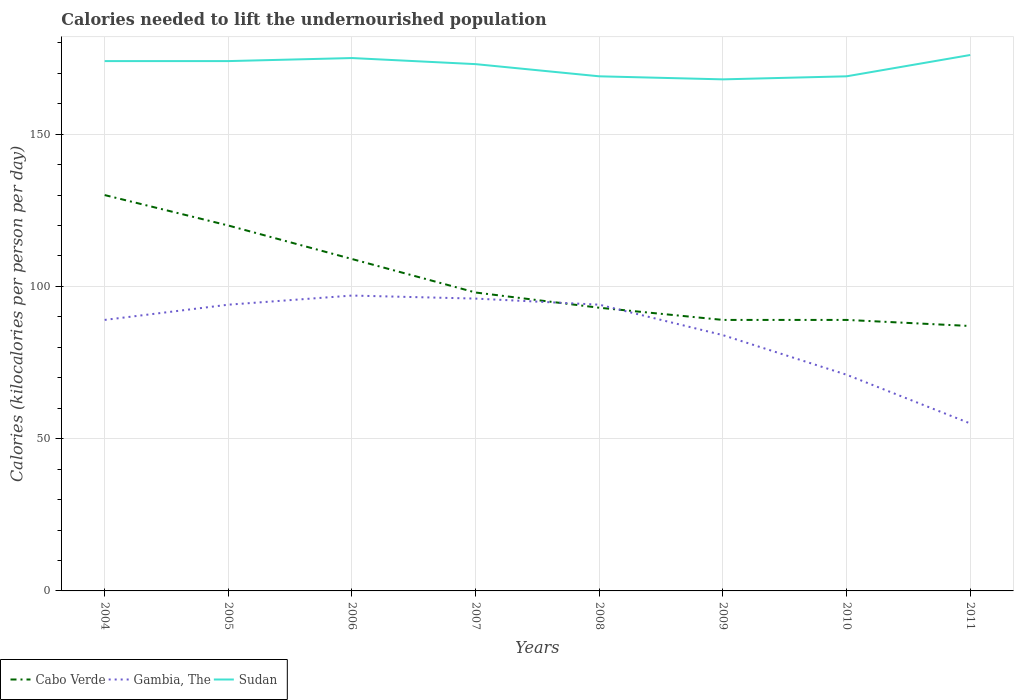How many different coloured lines are there?
Make the answer very short. 3. Does the line corresponding to Cabo Verde intersect with the line corresponding to Sudan?
Provide a succinct answer. No. Across all years, what is the maximum total calories needed to lift the undernourished population in Gambia, The?
Keep it short and to the point. 55. In which year was the total calories needed to lift the undernourished population in Gambia, The maximum?
Provide a succinct answer. 2011. What is the total total calories needed to lift the undernourished population in Gambia, The in the graph?
Give a very brief answer. -7. What is the difference between the highest and the second highest total calories needed to lift the undernourished population in Gambia, The?
Keep it short and to the point. 42. Is the total calories needed to lift the undernourished population in Cabo Verde strictly greater than the total calories needed to lift the undernourished population in Gambia, The over the years?
Your answer should be very brief. No. What is the difference between two consecutive major ticks on the Y-axis?
Provide a short and direct response. 50. Does the graph contain any zero values?
Provide a short and direct response. No. Where does the legend appear in the graph?
Give a very brief answer. Bottom left. How many legend labels are there?
Keep it short and to the point. 3. How are the legend labels stacked?
Provide a short and direct response. Horizontal. What is the title of the graph?
Keep it short and to the point. Calories needed to lift the undernourished population. Does "Sweden" appear as one of the legend labels in the graph?
Provide a short and direct response. No. What is the label or title of the Y-axis?
Your answer should be very brief. Calories (kilocalories per person per day). What is the Calories (kilocalories per person per day) in Cabo Verde in 2004?
Offer a very short reply. 130. What is the Calories (kilocalories per person per day) of Gambia, The in 2004?
Offer a very short reply. 89. What is the Calories (kilocalories per person per day) of Sudan in 2004?
Offer a very short reply. 174. What is the Calories (kilocalories per person per day) in Cabo Verde in 2005?
Provide a succinct answer. 120. What is the Calories (kilocalories per person per day) in Gambia, The in 2005?
Offer a terse response. 94. What is the Calories (kilocalories per person per day) of Sudan in 2005?
Provide a succinct answer. 174. What is the Calories (kilocalories per person per day) in Cabo Verde in 2006?
Offer a terse response. 109. What is the Calories (kilocalories per person per day) of Gambia, The in 2006?
Ensure brevity in your answer.  97. What is the Calories (kilocalories per person per day) of Sudan in 2006?
Give a very brief answer. 175. What is the Calories (kilocalories per person per day) in Gambia, The in 2007?
Make the answer very short. 96. What is the Calories (kilocalories per person per day) of Sudan in 2007?
Provide a short and direct response. 173. What is the Calories (kilocalories per person per day) of Cabo Verde in 2008?
Ensure brevity in your answer.  93. What is the Calories (kilocalories per person per day) of Gambia, The in 2008?
Your answer should be very brief. 94. What is the Calories (kilocalories per person per day) in Sudan in 2008?
Your answer should be compact. 169. What is the Calories (kilocalories per person per day) in Cabo Verde in 2009?
Your answer should be compact. 89. What is the Calories (kilocalories per person per day) of Sudan in 2009?
Offer a very short reply. 168. What is the Calories (kilocalories per person per day) of Cabo Verde in 2010?
Your response must be concise. 89. What is the Calories (kilocalories per person per day) of Sudan in 2010?
Offer a very short reply. 169. What is the Calories (kilocalories per person per day) of Cabo Verde in 2011?
Provide a short and direct response. 87. What is the Calories (kilocalories per person per day) in Sudan in 2011?
Make the answer very short. 176. Across all years, what is the maximum Calories (kilocalories per person per day) of Cabo Verde?
Your answer should be compact. 130. Across all years, what is the maximum Calories (kilocalories per person per day) in Gambia, The?
Give a very brief answer. 97. Across all years, what is the maximum Calories (kilocalories per person per day) of Sudan?
Ensure brevity in your answer.  176. Across all years, what is the minimum Calories (kilocalories per person per day) of Cabo Verde?
Your answer should be compact. 87. Across all years, what is the minimum Calories (kilocalories per person per day) in Sudan?
Give a very brief answer. 168. What is the total Calories (kilocalories per person per day) in Cabo Verde in the graph?
Your response must be concise. 815. What is the total Calories (kilocalories per person per day) of Gambia, The in the graph?
Your answer should be very brief. 680. What is the total Calories (kilocalories per person per day) in Sudan in the graph?
Make the answer very short. 1378. What is the difference between the Calories (kilocalories per person per day) in Cabo Verde in 2004 and that in 2005?
Give a very brief answer. 10. What is the difference between the Calories (kilocalories per person per day) of Sudan in 2004 and that in 2005?
Your answer should be very brief. 0. What is the difference between the Calories (kilocalories per person per day) in Gambia, The in 2004 and that in 2006?
Provide a succinct answer. -8. What is the difference between the Calories (kilocalories per person per day) in Gambia, The in 2004 and that in 2007?
Offer a very short reply. -7. What is the difference between the Calories (kilocalories per person per day) in Sudan in 2004 and that in 2007?
Your response must be concise. 1. What is the difference between the Calories (kilocalories per person per day) of Gambia, The in 2004 and that in 2008?
Provide a short and direct response. -5. What is the difference between the Calories (kilocalories per person per day) in Cabo Verde in 2004 and that in 2009?
Provide a succinct answer. 41. What is the difference between the Calories (kilocalories per person per day) of Sudan in 2004 and that in 2009?
Provide a succinct answer. 6. What is the difference between the Calories (kilocalories per person per day) in Gambia, The in 2004 and that in 2010?
Keep it short and to the point. 18. What is the difference between the Calories (kilocalories per person per day) of Sudan in 2004 and that in 2010?
Make the answer very short. 5. What is the difference between the Calories (kilocalories per person per day) of Gambia, The in 2005 and that in 2006?
Provide a short and direct response. -3. What is the difference between the Calories (kilocalories per person per day) in Sudan in 2005 and that in 2006?
Your answer should be compact. -1. What is the difference between the Calories (kilocalories per person per day) of Gambia, The in 2005 and that in 2007?
Give a very brief answer. -2. What is the difference between the Calories (kilocalories per person per day) of Sudan in 2005 and that in 2007?
Provide a short and direct response. 1. What is the difference between the Calories (kilocalories per person per day) of Cabo Verde in 2005 and that in 2008?
Provide a succinct answer. 27. What is the difference between the Calories (kilocalories per person per day) in Cabo Verde in 2005 and that in 2009?
Provide a short and direct response. 31. What is the difference between the Calories (kilocalories per person per day) in Gambia, The in 2005 and that in 2009?
Your answer should be compact. 10. What is the difference between the Calories (kilocalories per person per day) in Cabo Verde in 2005 and that in 2010?
Your answer should be compact. 31. What is the difference between the Calories (kilocalories per person per day) in Sudan in 2005 and that in 2011?
Make the answer very short. -2. What is the difference between the Calories (kilocalories per person per day) of Sudan in 2006 and that in 2007?
Provide a succinct answer. 2. What is the difference between the Calories (kilocalories per person per day) in Cabo Verde in 2006 and that in 2008?
Offer a terse response. 16. What is the difference between the Calories (kilocalories per person per day) in Gambia, The in 2006 and that in 2008?
Provide a short and direct response. 3. What is the difference between the Calories (kilocalories per person per day) of Cabo Verde in 2006 and that in 2009?
Offer a very short reply. 20. What is the difference between the Calories (kilocalories per person per day) in Gambia, The in 2006 and that in 2009?
Provide a succinct answer. 13. What is the difference between the Calories (kilocalories per person per day) in Sudan in 2006 and that in 2009?
Provide a short and direct response. 7. What is the difference between the Calories (kilocalories per person per day) in Sudan in 2006 and that in 2010?
Offer a very short reply. 6. What is the difference between the Calories (kilocalories per person per day) in Cabo Verde in 2007 and that in 2009?
Provide a short and direct response. 9. What is the difference between the Calories (kilocalories per person per day) of Gambia, The in 2007 and that in 2009?
Offer a very short reply. 12. What is the difference between the Calories (kilocalories per person per day) of Gambia, The in 2007 and that in 2010?
Your response must be concise. 25. What is the difference between the Calories (kilocalories per person per day) in Gambia, The in 2008 and that in 2009?
Offer a terse response. 10. What is the difference between the Calories (kilocalories per person per day) of Sudan in 2008 and that in 2009?
Ensure brevity in your answer.  1. What is the difference between the Calories (kilocalories per person per day) in Cabo Verde in 2008 and that in 2010?
Your answer should be compact. 4. What is the difference between the Calories (kilocalories per person per day) of Sudan in 2008 and that in 2010?
Give a very brief answer. 0. What is the difference between the Calories (kilocalories per person per day) in Sudan in 2008 and that in 2011?
Ensure brevity in your answer.  -7. What is the difference between the Calories (kilocalories per person per day) of Cabo Verde in 2009 and that in 2010?
Ensure brevity in your answer.  0. What is the difference between the Calories (kilocalories per person per day) of Gambia, The in 2009 and that in 2010?
Offer a very short reply. 13. What is the difference between the Calories (kilocalories per person per day) of Sudan in 2009 and that in 2010?
Your response must be concise. -1. What is the difference between the Calories (kilocalories per person per day) in Cabo Verde in 2009 and that in 2011?
Your answer should be very brief. 2. What is the difference between the Calories (kilocalories per person per day) of Cabo Verde in 2010 and that in 2011?
Ensure brevity in your answer.  2. What is the difference between the Calories (kilocalories per person per day) of Sudan in 2010 and that in 2011?
Offer a very short reply. -7. What is the difference between the Calories (kilocalories per person per day) in Cabo Verde in 2004 and the Calories (kilocalories per person per day) in Gambia, The in 2005?
Ensure brevity in your answer.  36. What is the difference between the Calories (kilocalories per person per day) in Cabo Verde in 2004 and the Calories (kilocalories per person per day) in Sudan in 2005?
Your answer should be very brief. -44. What is the difference between the Calories (kilocalories per person per day) in Gambia, The in 2004 and the Calories (kilocalories per person per day) in Sudan in 2005?
Your response must be concise. -85. What is the difference between the Calories (kilocalories per person per day) of Cabo Verde in 2004 and the Calories (kilocalories per person per day) of Sudan in 2006?
Provide a succinct answer. -45. What is the difference between the Calories (kilocalories per person per day) in Gambia, The in 2004 and the Calories (kilocalories per person per day) in Sudan in 2006?
Make the answer very short. -86. What is the difference between the Calories (kilocalories per person per day) in Cabo Verde in 2004 and the Calories (kilocalories per person per day) in Sudan in 2007?
Provide a succinct answer. -43. What is the difference between the Calories (kilocalories per person per day) of Gambia, The in 2004 and the Calories (kilocalories per person per day) of Sudan in 2007?
Offer a very short reply. -84. What is the difference between the Calories (kilocalories per person per day) in Cabo Verde in 2004 and the Calories (kilocalories per person per day) in Gambia, The in 2008?
Offer a very short reply. 36. What is the difference between the Calories (kilocalories per person per day) in Cabo Verde in 2004 and the Calories (kilocalories per person per day) in Sudan in 2008?
Your answer should be very brief. -39. What is the difference between the Calories (kilocalories per person per day) of Gambia, The in 2004 and the Calories (kilocalories per person per day) of Sudan in 2008?
Your response must be concise. -80. What is the difference between the Calories (kilocalories per person per day) in Cabo Verde in 2004 and the Calories (kilocalories per person per day) in Sudan in 2009?
Make the answer very short. -38. What is the difference between the Calories (kilocalories per person per day) of Gambia, The in 2004 and the Calories (kilocalories per person per day) of Sudan in 2009?
Your response must be concise. -79. What is the difference between the Calories (kilocalories per person per day) in Cabo Verde in 2004 and the Calories (kilocalories per person per day) in Sudan in 2010?
Give a very brief answer. -39. What is the difference between the Calories (kilocalories per person per day) in Gambia, The in 2004 and the Calories (kilocalories per person per day) in Sudan in 2010?
Your response must be concise. -80. What is the difference between the Calories (kilocalories per person per day) in Cabo Verde in 2004 and the Calories (kilocalories per person per day) in Gambia, The in 2011?
Provide a succinct answer. 75. What is the difference between the Calories (kilocalories per person per day) in Cabo Verde in 2004 and the Calories (kilocalories per person per day) in Sudan in 2011?
Give a very brief answer. -46. What is the difference between the Calories (kilocalories per person per day) in Gambia, The in 2004 and the Calories (kilocalories per person per day) in Sudan in 2011?
Your response must be concise. -87. What is the difference between the Calories (kilocalories per person per day) in Cabo Verde in 2005 and the Calories (kilocalories per person per day) in Gambia, The in 2006?
Your response must be concise. 23. What is the difference between the Calories (kilocalories per person per day) in Cabo Verde in 2005 and the Calories (kilocalories per person per day) in Sudan in 2006?
Give a very brief answer. -55. What is the difference between the Calories (kilocalories per person per day) of Gambia, The in 2005 and the Calories (kilocalories per person per day) of Sudan in 2006?
Keep it short and to the point. -81. What is the difference between the Calories (kilocalories per person per day) of Cabo Verde in 2005 and the Calories (kilocalories per person per day) of Gambia, The in 2007?
Your response must be concise. 24. What is the difference between the Calories (kilocalories per person per day) of Cabo Verde in 2005 and the Calories (kilocalories per person per day) of Sudan in 2007?
Give a very brief answer. -53. What is the difference between the Calories (kilocalories per person per day) of Gambia, The in 2005 and the Calories (kilocalories per person per day) of Sudan in 2007?
Offer a terse response. -79. What is the difference between the Calories (kilocalories per person per day) of Cabo Verde in 2005 and the Calories (kilocalories per person per day) of Sudan in 2008?
Keep it short and to the point. -49. What is the difference between the Calories (kilocalories per person per day) of Gambia, The in 2005 and the Calories (kilocalories per person per day) of Sudan in 2008?
Provide a short and direct response. -75. What is the difference between the Calories (kilocalories per person per day) in Cabo Verde in 2005 and the Calories (kilocalories per person per day) in Sudan in 2009?
Give a very brief answer. -48. What is the difference between the Calories (kilocalories per person per day) in Gambia, The in 2005 and the Calories (kilocalories per person per day) in Sudan in 2009?
Your response must be concise. -74. What is the difference between the Calories (kilocalories per person per day) in Cabo Verde in 2005 and the Calories (kilocalories per person per day) in Gambia, The in 2010?
Provide a succinct answer. 49. What is the difference between the Calories (kilocalories per person per day) in Cabo Verde in 2005 and the Calories (kilocalories per person per day) in Sudan in 2010?
Your answer should be very brief. -49. What is the difference between the Calories (kilocalories per person per day) of Gambia, The in 2005 and the Calories (kilocalories per person per day) of Sudan in 2010?
Your answer should be compact. -75. What is the difference between the Calories (kilocalories per person per day) of Cabo Verde in 2005 and the Calories (kilocalories per person per day) of Gambia, The in 2011?
Keep it short and to the point. 65. What is the difference between the Calories (kilocalories per person per day) of Cabo Verde in 2005 and the Calories (kilocalories per person per day) of Sudan in 2011?
Give a very brief answer. -56. What is the difference between the Calories (kilocalories per person per day) of Gambia, The in 2005 and the Calories (kilocalories per person per day) of Sudan in 2011?
Provide a short and direct response. -82. What is the difference between the Calories (kilocalories per person per day) of Cabo Verde in 2006 and the Calories (kilocalories per person per day) of Sudan in 2007?
Your answer should be compact. -64. What is the difference between the Calories (kilocalories per person per day) in Gambia, The in 2006 and the Calories (kilocalories per person per day) in Sudan in 2007?
Offer a terse response. -76. What is the difference between the Calories (kilocalories per person per day) of Cabo Verde in 2006 and the Calories (kilocalories per person per day) of Gambia, The in 2008?
Make the answer very short. 15. What is the difference between the Calories (kilocalories per person per day) in Cabo Verde in 2006 and the Calories (kilocalories per person per day) in Sudan in 2008?
Make the answer very short. -60. What is the difference between the Calories (kilocalories per person per day) in Gambia, The in 2006 and the Calories (kilocalories per person per day) in Sudan in 2008?
Your answer should be compact. -72. What is the difference between the Calories (kilocalories per person per day) in Cabo Verde in 2006 and the Calories (kilocalories per person per day) in Gambia, The in 2009?
Offer a terse response. 25. What is the difference between the Calories (kilocalories per person per day) of Cabo Verde in 2006 and the Calories (kilocalories per person per day) of Sudan in 2009?
Provide a succinct answer. -59. What is the difference between the Calories (kilocalories per person per day) of Gambia, The in 2006 and the Calories (kilocalories per person per day) of Sudan in 2009?
Offer a terse response. -71. What is the difference between the Calories (kilocalories per person per day) of Cabo Verde in 2006 and the Calories (kilocalories per person per day) of Sudan in 2010?
Your answer should be very brief. -60. What is the difference between the Calories (kilocalories per person per day) of Gambia, The in 2006 and the Calories (kilocalories per person per day) of Sudan in 2010?
Your response must be concise. -72. What is the difference between the Calories (kilocalories per person per day) of Cabo Verde in 2006 and the Calories (kilocalories per person per day) of Gambia, The in 2011?
Offer a terse response. 54. What is the difference between the Calories (kilocalories per person per day) in Cabo Verde in 2006 and the Calories (kilocalories per person per day) in Sudan in 2011?
Offer a terse response. -67. What is the difference between the Calories (kilocalories per person per day) of Gambia, The in 2006 and the Calories (kilocalories per person per day) of Sudan in 2011?
Offer a terse response. -79. What is the difference between the Calories (kilocalories per person per day) in Cabo Verde in 2007 and the Calories (kilocalories per person per day) in Sudan in 2008?
Provide a short and direct response. -71. What is the difference between the Calories (kilocalories per person per day) in Gambia, The in 2007 and the Calories (kilocalories per person per day) in Sudan in 2008?
Offer a very short reply. -73. What is the difference between the Calories (kilocalories per person per day) of Cabo Verde in 2007 and the Calories (kilocalories per person per day) of Sudan in 2009?
Offer a very short reply. -70. What is the difference between the Calories (kilocalories per person per day) in Gambia, The in 2007 and the Calories (kilocalories per person per day) in Sudan in 2009?
Make the answer very short. -72. What is the difference between the Calories (kilocalories per person per day) of Cabo Verde in 2007 and the Calories (kilocalories per person per day) of Gambia, The in 2010?
Provide a short and direct response. 27. What is the difference between the Calories (kilocalories per person per day) of Cabo Verde in 2007 and the Calories (kilocalories per person per day) of Sudan in 2010?
Your answer should be compact. -71. What is the difference between the Calories (kilocalories per person per day) in Gambia, The in 2007 and the Calories (kilocalories per person per day) in Sudan in 2010?
Provide a succinct answer. -73. What is the difference between the Calories (kilocalories per person per day) in Cabo Verde in 2007 and the Calories (kilocalories per person per day) in Sudan in 2011?
Offer a very short reply. -78. What is the difference between the Calories (kilocalories per person per day) of Gambia, The in 2007 and the Calories (kilocalories per person per day) of Sudan in 2011?
Provide a short and direct response. -80. What is the difference between the Calories (kilocalories per person per day) of Cabo Verde in 2008 and the Calories (kilocalories per person per day) of Sudan in 2009?
Your response must be concise. -75. What is the difference between the Calories (kilocalories per person per day) of Gambia, The in 2008 and the Calories (kilocalories per person per day) of Sudan in 2009?
Offer a terse response. -74. What is the difference between the Calories (kilocalories per person per day) of Cabo Verde in 2008 and the Calories (kilocalories per person per day) of Gambia, The in 2010?
Give a very brief answer. 22. What is the difference between the Calories (kilocalories per person per day) of Cabo Verde in 2008 and the Calories (kilocalories per person per day) of Sudan in 2010?
Make the answer very short. -76. What is the difference between the Calories (kilocalories per person per day) of Gambia, The in 2008 and the Calories (kilocalories per person per day) of Sudan in 2010?
Your response must be concise. -75. What is the difference between the Calories (kilocalories per person per day) of Cabo Verde in 2008 and the Calories (kilocalories per person per day) of Gambia, The in 2011?
Your answer should be compact. 38. What is the difference between the Calories (kilocalories per person per day) of Cabo Verde in 2008 and the Calories (kilocalories per person per day) of Sudan in 2011?
Provide a succinct answer. -83. What is the difference between the Calories (kilocalories per person per day) of Gambia, The in 2008 and the Calories (kilocalories per person per day) of Sudan in 2011?
Provide a succinct answer. -82. What is the difference between the Calories (kilocalories per person per day) in Cabo Verde in 2009 and the Calories (kilocalories per person per day) in Sudan in 2010?
Offer a terse response. -80. What is the difference between the Calories (kilocalories per person per day) in Gambia, The in 2009 and the Calories (kilocalories per person per day) in Sudan in 2010?
Make the answer very short. -85. What is the difference between the Calories (kilocalories per person per day) in Cabo Verde in 2009 and the Calories (kilocalories per person per day) in Sudan in 2011?
Your response must be concise. -87. What is the difference between the Calories (kilocalories per person per day) of Gambia, The in 2009 and the Calories (kilocalories per person per day) of Sudan in 2011?
Offer a terse response. -92. What is the difference between the Calories (kilocalories per person per day) of Cabo Verde in 2010 and the Calories (kilocalories per person per day) of Gambia, The in 2011?
Your answer should be very brief. 34. What is the difference between the Calories (kilocalories per person per day) in Cabo Verde in 2010 and the Calories (kilocalories per person per day) in Sudan in 2011?
Give a very brief answer. -87. What is the difference between the Calories (kilocalories per person per day) in Gambia, The in 2010 and the Calories (kilocalories per person per day) in Sudan in 2011?
Keep it short and to the point. -105. What is the average Calories (kilocalories per person per day) of Cabo Verde per year?
Give a very brief answer. 101.88. What is the average Calories (kilocalories per person per day) of Sudan per year?
Make the answer very short. 172.25. In the year 2004, what is the difference between the Calories (kilocalories per person per day) in Cabo Verde and Calories (kilocalories per person per day) in Gambia, The?
Provide a succinct answer. 41. In the year 2004, what is the difference between the Calories (kilocalories per person per day) in Cabo Verde and Calories (kilocalories per person per day) in Sudan?
Keep it short and to the point. -44. In the year 2004, what is the difference between the Calories (kilocalories per person per day) of Gambia, The and Calories (kilocalories per person per day) of Sudan?
Your response must be concise. -85. In the year 2005, what is the difference between the Calories (kilocalories per person per day) in Cabo Verde and Calories (kilocalories per person per day) in Gambia, The?
Your answer should be compact. 26. In the year 2005, what is the difference between the Calories (kilocalories per person per day) in Cabo Verde and Calories (kilocalories per person per day) in Sudan?
Your answer should be compact. -54. In the year 2005, what is the difference between the Calories (kilocalories per person per day) in Gambia, The and Calories (kilocalories per person per day) in Sudan?
Make the answer very short. -80. In the year 2006, what is the difference between the Calories (kilocalories per person per day) of Cabo Verde and Calories (kilocalories per person per day) of Sudan?
Offer a very short reply. -66. In the year 2006, what is the difference between the Calories (kilocalories per person per day) in Gambia, The and Calories (kilocalories per person per day) in Sudan?
Give a very brief answer. -78. In the year 2007, what is the difference between the Calories (kilocalories per person per day) in Cabo Verde and Calories (kilocalories per person per day) in Gambia, The?
Give a very brief answer. 2. In the year 2007, what is the difference between the Calories (kilocalories per person per day) in Cabo Verde and Calories (kilocalories per person per day) in Sudan?
Give a very brief answer. -75. In the year 2007, what is the difference between the Calories (kilocalories per person per day) of Gambia, The and Calories (kilocalories per person per day) of Sudan?
Keep it short and to the point. -77. In the year 2008, what is the difference between the Calories (kilocalories per person per day) of Cabo Verde and Calories (kilocalories per person per day) of Gambia, The?
Give a very brief answer. -1. In the year 2008, what is the difference between the Calories (kilocalories per person per day) of Cabo Verde and Calories (kilocalories per person per day) of Sudan?
Your response must be concise. -76. In the year 2008, what is the difference between the Calories (kilocalories per person per day) of Gambia, The and Calories (kilocalories per person per day) of Sudan?
Offer a very short reply. -75. In the year 2009, what is the difference between the Calories (kilocalories per person per day) of Cabo Verde and Calories (kilocalories per person per day) of Sudan?
Your response must be concise. -79. In the year 2009, what is the difference between the Calories (kilocalories per person per day) of Gambia, The and Calories (kilocalories per person per day) of Sudan?
Offer a very short reply. -84. In the year 2010, what is the difference between the Calories (kilocalories per person per day) of Cabo Verde and Calories (kilocalories per person per day) of Sudan?
Give a very brief answer. -80. In the year 2010, what is the difference between the Calories (kilocalories per person per day) of Gambia, The and Calories (kilocalories per person per day) of Sudan?
Your answer should be very brief. -98. In the year 2011, what is the difference between the Calories (kilocalories per person per day) in Cabo Verde and Calories (kilocalories per person per day) in Sudan?
Keep it short and to the point. -89. In the year 2011, what is the difference between the Calories (kilocalories per person per day) of Gambia, The and Calories (kilocalories per person per day) of Sudan?
Keep it short and to the point. -121. What is the ratio of the Calories (kilocalories per person per day) in Gambia, The in 2004 to that in 2005?
Your answer should be compact. 0.95. What is the ratio of the Calories (kilocalories per person per day) in Sudan in 2004 to that in 2005?
Offer a terse response. 1. What is the ratio of the Calories (kilocalories per person per day) in Cabo Verde in 2004 to that in 2006?
Keep it short and to the point. 1.19. What is the ratio of the Calories (kilocalories per person per day) in Gambia, The in 2004 to that in 2006?
Your response must be concise. 0.92. What is the ratio of the Calories (kilocalories per person per day) in Cabo Verde in 2004 to that in 2007?
Your response must be concise. 1.33. What is the ratio of the Calories (kilocalories per person per day) of Gambia, The in 2004 to that in 2007?
Give a very brief answer. 0.93. What is the ratio of the Calories (kilocalories per person per day) of Sudan in 2004 to that in 2007?
Give a very brief answer. 1.01. What is the ratio of the Calories (kilocalories per person per day) of Cabo Verde in 2004 to that in 2008?
Your response must be concise. 1.4. What is the ratio of the Calories (kilocalories per person per day) in Gambia, The in 2004 to that in 2008?
Make the answer very short. 0.95. What is the ratio of the Calories (kilocalories per person per day) of Sudan in 2004 to that in 2008?
Provide a short and direct response. 1.03. What is the ratio of the Calories (kilocalories per person per day) in Cabo Verde in 2004 to that in 2009?
Make the answer very short. 1.46. What is the ratio of the Calories (kilocalories per person per day) in Gambia, The in 2004 to that in 2009?
Ensure brevity in your answer.  1.06. What is the ratio of the Calories (kilocalories per person per day) in Sudan in 2004 to that in 2009?
Give a very brief answer. 1.04. What is the ratio of the Calories (kilocalories per person per day) in Cabo Verde in 2004 to that in 2010?
Offer a very short reply. 1.46. What is the ratio of the Calories (kilocalories per person per day) in Gambia, The in 2004 to that in 2010?
Make the answer very short. 1.25. What is the ratio of the Calories (kilocalories per person per day) of Sudan in 2004 to that in 2010?
Give a very brief answer. 1.03. What is the ratio of the Calories (kilocalories per person per day) in Cabo Verde in 2004 to that in 2011?
Give a very brief answer. 1.49. What is the ratio of the Calories (kilocalories per person per day) of Gambia, The in 2004 to that in 2011?
Your response must be concise. 1.62. What is the ratio of the Calories (kilocalories per person per day) in Sudan in 2004 to that in 2011?
Your response must be concise. 0.99. What is the ratio of the Calories (kilocalories per person per day) in Cabo Verde in 2005 to that in 2006?
Provide a short and direct response. 1.1. What is the ratio of the Calories (kilocalories per person per day) in Gambia, The in 2005 to that in 2006?
Keep it short and to the point. 0.97. What is the ratio of the Calories (kilocalories per person per day) of Cabo Verde in 2005 to that in 2007?
Your answer should be very brief. 1.22. What is the ratio of the Calories (kilocalories per person per day) in Gambia, The in 2005 to that in 2007?
Provide a short and direct response. 0.98. What is the ratio of the Calories (kilocalories per person per day) of Cabo Verde in 2005 to that in 2008?
Offer a very short reply. 1.29. What is the ratio of the Calories (kilocalories per person per day) of Gambia, The in 2005 to that in 2008?
Provide a short and direct response. 1. What is the ratio of the Calories (kilocalories per person per day) of Sudan in 2005 to that in 2008?
Make the answer very short. 1.03. What is the ratio of the Calories (kilocalories per person per day) of Cabo Verde in 2005 to that in 2009?
Give a very brief answer. 1.35. What is the ratio of the Calories (kilocalories per person per day) in Gambia, The in 2005 to that in 2009?
Make the answer very short. 1.12. What is the ratio of the Calories (kilocalories per person per day) of Sudan in 2005 to that in 2009?
Your answer should be compact. 1.04. What is the ratio of the Calories (kilocalories per person per day) of Cabo Verde in 2005 to that in 2010?
Provide a short and direct response. 1.35. What is the ratio of the Calories (kilocalories per person per day) in Gambia, The in 2005 to that in 2010?
Your response must be concise. 1.32. What is the ratio of the Calories (kilocalories per person per day) in Sudan in 2005 to that in 2010?
Ensure brevity in your answer.  1.03. What is the ratio of the Calories (kilocalories per person per day) in Cabo Verde in 2005 to that in 2011?
Give a very brief answer. 1.38. What is the ratio of the Calories (kilocalories per person per day) of Gambia, The in 2005 to that in 2011?
Your answer should be very brief. 1.71. What is the ratio of the Calories (kilocalories per person per day) of Sudan in 2005 to that in 2011?
Keep it short and to the point. 0.99. What is the ratio of the Calories (kilocalories per person per day) in Cabo Verde in 2006 to that in 2007?
Provide a short and direct response. 1.11. What is the ratio of the Calories (kilocalories per person per day) of Gambia, The in 2006 to that in 2007?
Provide a succinct answer. 1.01. What is the ratio of the Calories (kilocalories per person per day) of Sudan in 2006 to that in 2007?
Provide a succinct answer. 1.01. What is the ratio of the Calories (kilocalories per person per day) in Cabo Verde in 2006 to that in 2008?
Your answer should be compact. 1.17. What is the ratio of the Calories (kilocalories per person per day) of Gambia, The in 2006 to that in 2008?
Your response must be concise. 1.03. What is the ratio of the Calories (kilocalories per person per day) in Sudan in 2006 to that in 2008?
Provide a succinct answer. 1.04. What is the ratio of the Calories (kilocalories per person per day) of Cabo Verde in 2006 to that in 2009?
Ensure brevity in your answer.  1.22. What is the ratio of the Calories (kilocalories per person per day) in Gambia, The in 2006 to that in 2009?
Provide a short and direct response. 1.15. What is the ratio of the Calories (kilocalories per person per day) in Sudan in 2006 to that in 2009?
Provide a succinct answer. 1.04. What is the ratio of the Calories (kilocalories per person per day) of Cabo Verde in 2006 to that in 2010?
Provide a succinct answer. 1.22. What is the ratio of the Calories (kilocalories per person per day) of Gambia, The in 2006 to that in 2010?
Give a very brief answer. 1.37. What is the ratio of the Calories (kilocalories per person per day) in Sudan in 2006 to that in 2010?
Ensure brevity in your answer.  1.04. What is the ratio of the Calories (kilocalories per person per day) in Cabo Verde in 2006 to that in 2011?
Provide a short and direct response. 1.25. What is the ratio of the Calories (kilocalories per person per day) of Gambia, The in 2006 to that in 2011?
Give a very brief answer. 1.76. What is the ratio of the Calories (kilocalories per person per day) of Sudan in 2006 to that in 2011?
Your answer should be very brief. 0.99. What is the ratio of the Calories (kilocalories per person per day) of Cabo Verde in 2007 to that in 2008?
Your answer should be compact. 1.05. What is the ratio of the Calories (kilocalories per person per day) in Gambia, The in 2007 to that in 2008?
Offer a terse response. 1.02. What is the ratio of the Calories (kilocalories per person per day) of Sudan in 2007 to that in 2008?
Your answer should be compact. 1.02. What is the ratio of the Calories (kilocalories per person per day) in Cabo Verde in 2007 to that in 2009?
Offer a very short reply. 1.1. What is the ratio of the Calories (kilocalories per person per day) of Sudan in 2007 to that in 2009?
Make the answer very short. 1.03. What is the ratio of the Calories (kilocalories per person per day) in Cabo Verde in 2007 to that in 2010?
Make the answer very short. 1.1. What is the ratio of the Calories (kilocalories per person per day) in Gambia, The in 2007 to that in 2010?
Your answer should be compact. 1.35. What is the ratio of the Calories (kilocalories per person per day) of Sudan in 2007 to that in 2010?
Make the answer very short. 1.02. What is the ratio of the Calories (kilocalories per person per day) in Cabo Verde in 2007 to that in 2011?
Provide a short and direct response. 1.13. What is the ratio of the Calories (kilocalories per person per day) in Gambia, The in 2007 to that in 2011?
Your answer should be compact. 1.75. What is the ratio of the Calories (kilocalories per person per day) of Cabo Verde in 2008 to that in 2009?
Ensure brevity in your answer.  1.04. What is the ratio of the Calories (kilocalories per person per day) of Gambia, The in 2008 to that in 2009?
Offer a terse response. 1.12. What is the ratio of the Calories (kilocalories per person per day) in Cabo Verde in 2008 to that in 2010?
Provide a short and direct response. 1.04. What is the ratio of the Calories (kilocalories per person per day) of Gambia, The in 2008 to that in 2010?
Give a very brief answer. 1.32. What is the ratio of the Calories (kilocalories per person per day) of Sudan in 2008 to that in 2010?
Provide a short and direct response. 1. What is the ratio of the Calories (kilocalories per person per day) in Cabo Verde in 2008 to that in 2011?
Keep it short and to the point. 1.07. What is the ratio of the Calories (kilocalories per person per day) of Gambia, The in 2008 to that in 2011?
Provide a short and direct response. 1.71. What is the ratio of the Calories (kilocalories per person per day) in Sudan in 2008 to that in 2011?
Keep it short and to the point. 0.96. What is the ratio of the Calories (kilocalories per person per day) in Cabo Verde in 2009 to that in 2010?
Your answer should be compact. 1. What is the ratio of the Calories (kilocalories per person per day) of Gambia, The in 2009 to that in 2010?
Offer a terse response. 1.18. What is the ratio of the Calories (kilocalories per person per day) of Sudan in 2009 to that in 2010?
Offer a very short reply. 0.99. What is the ratio of the Calories (kilocalories per person per day) of Cabo Verde in 2009 to that in 2011?
Keep it short and to the point. 1.02. What is the ratio of the Calories (kilocalories per person per day) of Gambia, The in 2009 to that in 2011?
Offer a terse response. 1.53. What is the ratio of the Calories (kilocalories per person per day) in Sudan in 2009 to that in 2011?
Make the answer very short. 0.95. What is the ratio of the Calories (kilocalories per person per day) in Cabo Verde in 2010 to that in 2011?
Provide a succinct answer. 1.02. What is the ratio of the Calories (kilocalories per person per day) of Gambia, The in 2010 to that in 2011?
Make the answer very short. 1.29. What is the ratio of the Calories (kilocalories per person per day) of Sudan in 2010 to that in 2011?
Provide a succinct answer. 0.96. What is the difference between the highest and the second highest Calories (kilocalories per person per day) of Gambia, The?
Provide a short and direct response. 1. What is the difference between the highest and the lowest Calories (kilocalories per person per day) in Cabo Verde?
Offer a terse response. 43. What is the difference between the highest and the lowest Calories (kilocalories per person per day) of Sudan?
Make the answer very short. 8. 